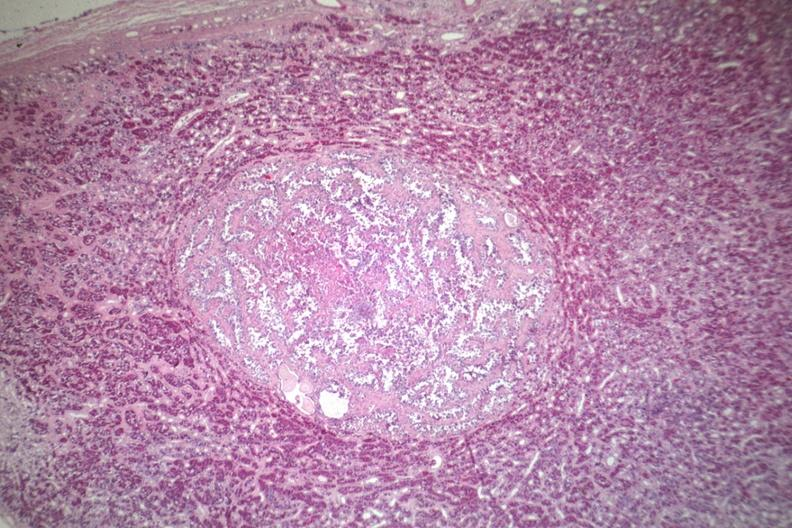s this photo of infant from head to toe present?
Answer the question using a single word or phrase. No 